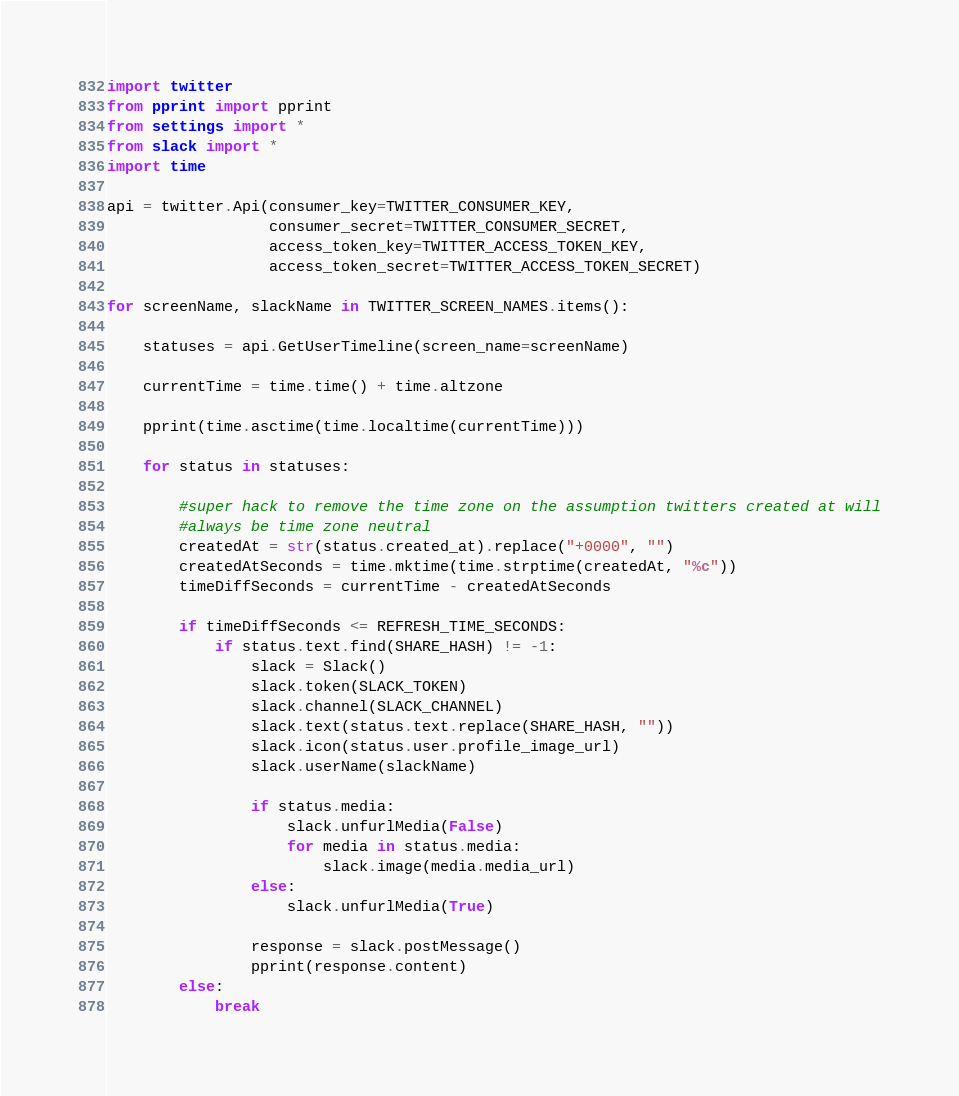<code> <loc_0><loc_0><loc_500><loc_500><_Python_>import twitter
from pprint import pprint
from settings import *
from slack import *
import time

api = twitter.Api(consumer_key=TWITTER_CONSUMER_KEY,
                  consumer_secret=TWITTER_CONSUMER_SECRET,
                  access_token_key=TWITTER_ACCESS_TOKEN_KEY,
                  access_token_secret=TWITTER_ACCESS_TOKEN_SECRET)

for screenName, slackName in TWITTER_SCREEN_NAMES.items():

    statuses = api.GetUserTimeline(screen_name=screenName)

    currentTime = time.time() + time.altzone

    pprint(time.asctime(time.localtime(currentTime)))

    for status in statuses:
        
        #super hack to remove the time zone on the assumption twitters created at will
        #always be time zone neutral
        createdAt = str(status.created_at).replace("+0000", "")
        createdAtSeconds = time.mktime(time.strptime(createdAt, "%c"))
        timeDiffSeconds = currentTime - createdAtSeconds

        if timeDiffSeconds <= REFRESH_TIME_SECONDS:  
            if status.text.find(SHARE_HASH) != -1:
                slack = Slack()
                slack.token(SLACK_TOKEN)
                slack.channel(SLACK_CHANNEL)  
                slack.text(status.text.replace(SHARE_HASH, ""))
                slack.icon(status.user.profile_image_url)
                slack.userName(slackName)

                if status.media:
                    slack.unfurlMedia(False)
                    for media in status.media:
                        slack.image(media.media_url)
                else:
                    slack.unfurlMedia(True)

                response = slack.postMessage()
                pprint(response.content)     
        else:
            break</code> 